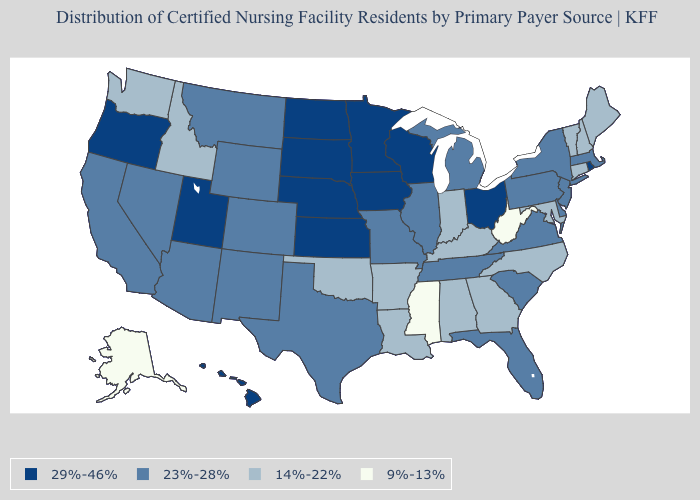Does Maine have the highest value in the Northeast?
Write a very short answer. No. Does Connecticut have a lower value than Arizona?
Short answer required. Yes. Name the states that have a value in the range 9%-13%?
Concise answer only. Alaska, Mississippi, West Virginia. What is the lowest value in states that border Arizona?
Keep it brief. 23%-28%. What is the value of Washington?
Keep it brief. 14%-22%. What is the value of Colorado?
Keep it brief. 23%-28%. Which states hav the highest value in the Northeast?
Concise answer only. Rhode Island. Does Nevada have the highest value in the USA?
Give a very brief answer. No. Does New Mexico have the highest value in the USA?
Write a very short answer. No. Name the states that have a value in the range 14%-22%?
Concise answer only. Alabama, Arkansas, Connecticut, Georgia, Idaho, Indiana, Kentucky, Louisiana, Maine, Maryland, New Hampshire, North Carolina, Oklahoma, Vermont, Washington. Among the states that border Connecticut , does Massachusetts have the highest value?
Be succinct. No. What is the lowest value in states that border Alabama?
Write a very short answer. 9%-13%. Among the states that border Arkansas , which have the highest value?
Answer briefly. Missouri, Tennessee, Texas. What is the lowest value in the Northeast?
Give a very brief answer. 14%-22%. What is the value of Connecticut?
Quick response, please. 14%-22%. 